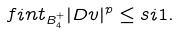Convert formula to latex. <formula><loc_0><loc_0><loc_500><loc_500>\ f i n t _ { B _ { 4 } ^ { + } } | D v | ^ { p } \leq s i 1 .</formula> 